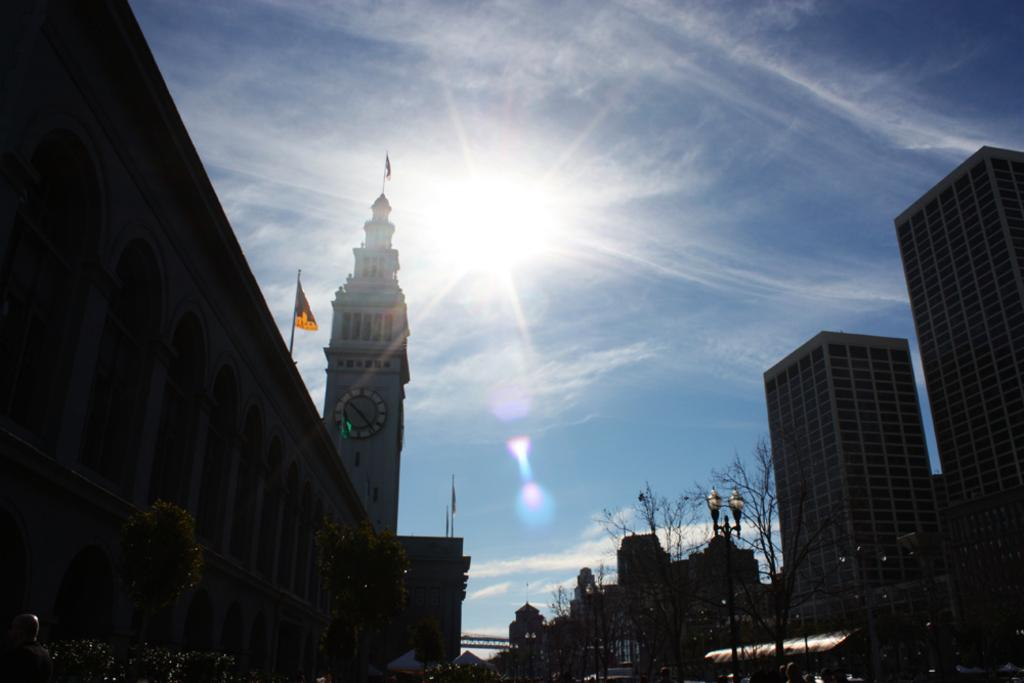What type of structures can be seen in the image? There are buildings in the image. What other natural elements are present in the image? There are trees in the image. What type of man-made object can be seen in the image? There is a street light in the image. What decorative elements are present in the image? There are flags in the image. What can be seen in the background of the image? The sun and the sky are visible in the background of the image. Where is the toy hidden in the image? There is no toy present in the image. What type of box is used to store the afterthoughts in the image? There is no box or afterthoughts present in the image. 